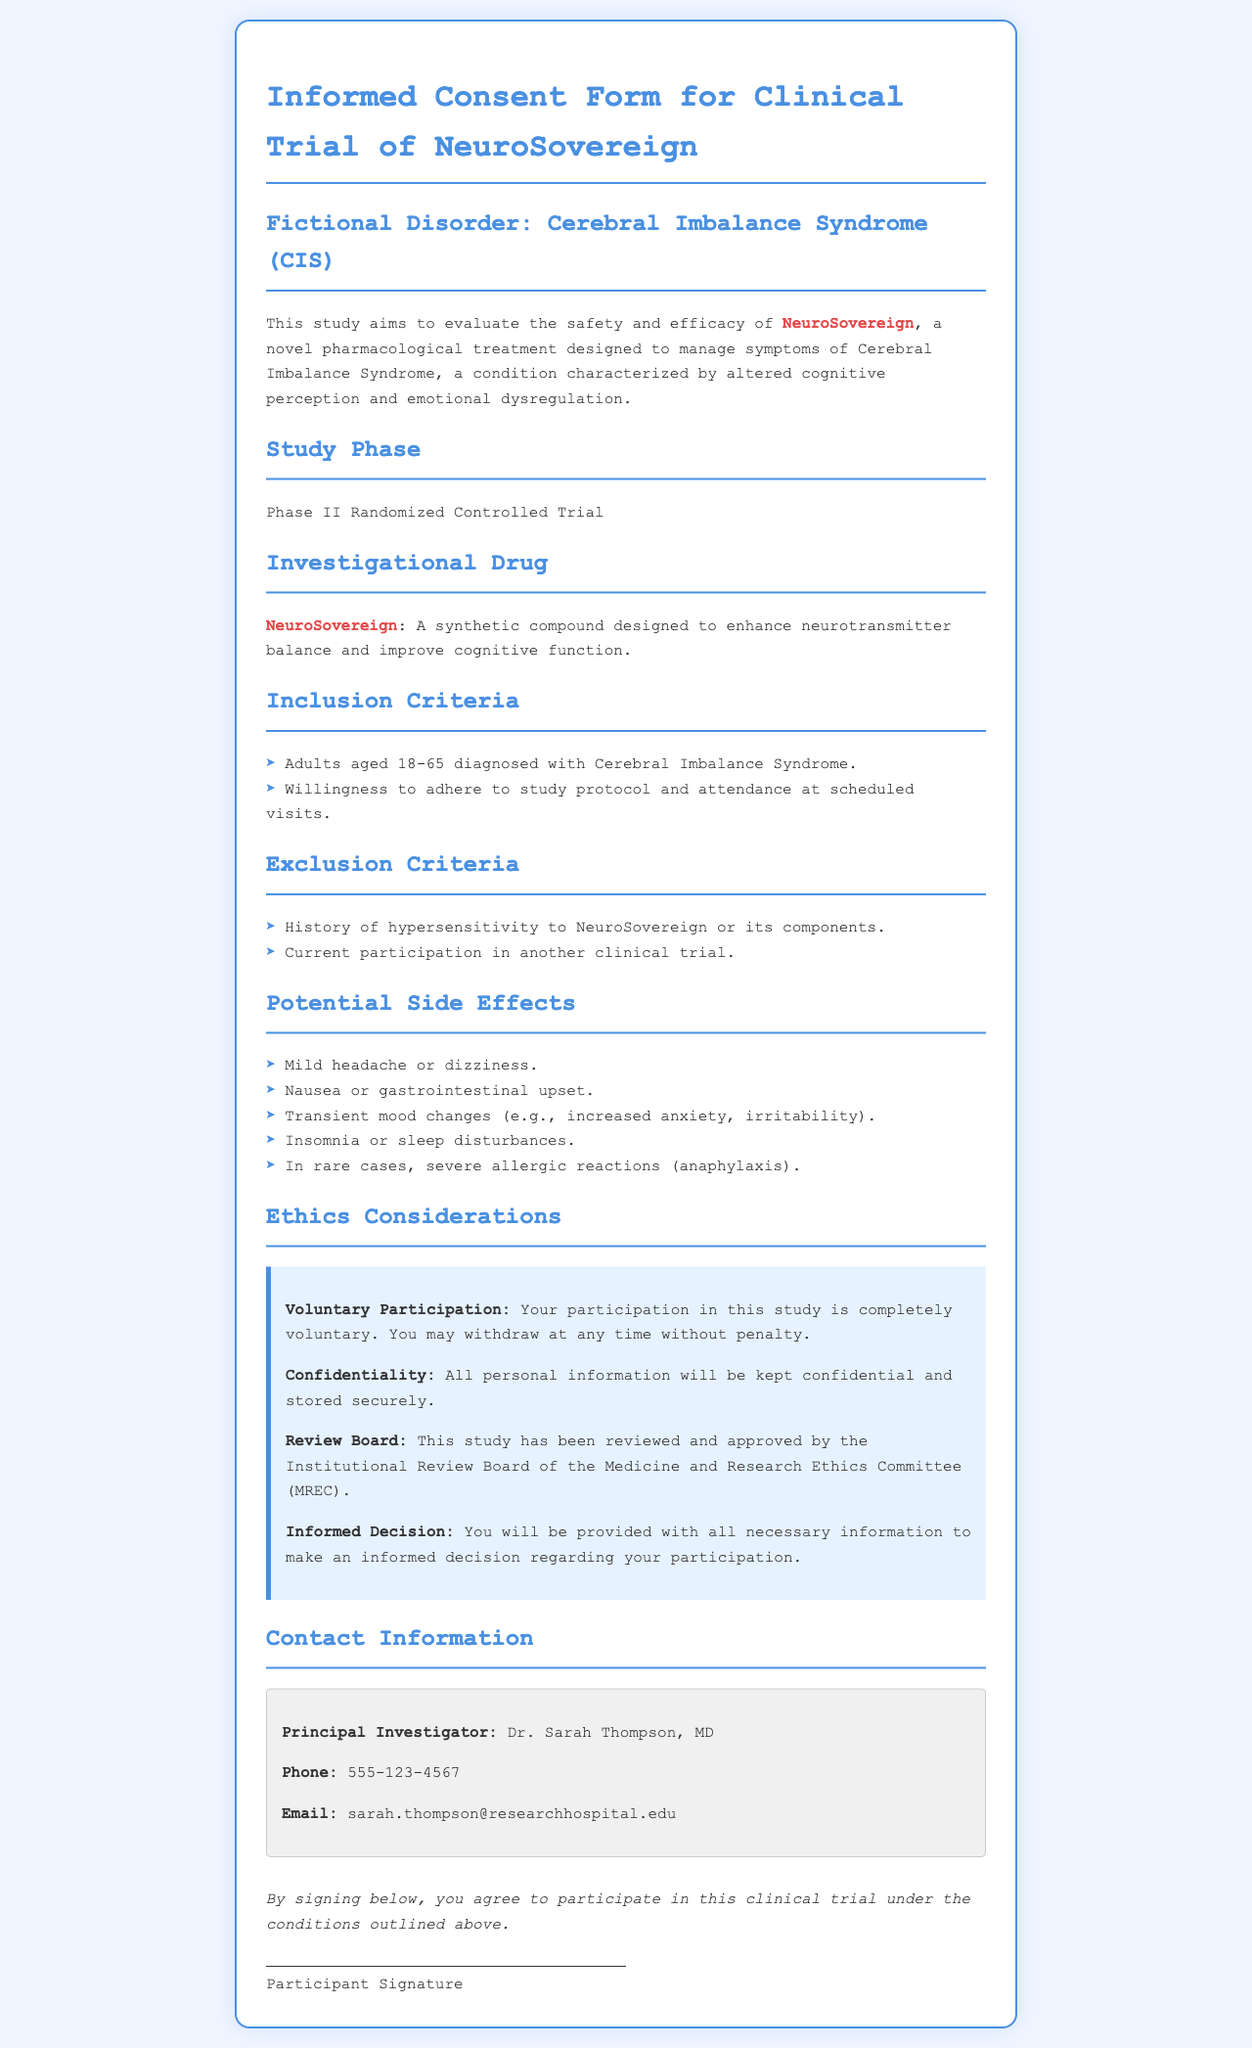What is the name of the investigational drug? The name of the investigational drug stated in the document is NeuroSovereign.
Answer: NeuroSovereign What is the age range for inclusion in the study? The document specifies that participants must be adults aged 18-65 to meet the inclusion criteria.
Answer: 18-65 What is one potential side effect listed? The document lists several potential side effects of the drug, including mild headache or dizziness as one of them.
Answer: Mild headache or dizziness Who is the principal investigator? The document mentions Dr. Sarah Thompson, MD, as the principal investigator leading the clinical trial.
Answer: Dr. Sarah Thompson, MD What does the ethics consideration state about participation? The ethics consideration states that participation is completely voluntary, allowing individuals to withdraw at any time without penalty.
Answer: Voluntary What is the purpose of the NeuroSovereign clinical trial? The study aims to evaluate the safety and efficacy of NeuroSovereign for managing symptoms of Cerebral Imbalance Syndrome.
Answer: Safety and efficacy How many exclusion criteria are listed in the document? There are two exclusion criteria mentioned in the document regarding participation in the clinical trial.
Answer: 2 What should participants sign to agree to the trial? Participants are required to sign the signature line at the bottom of the document to indicate their agreement to participate.
Answer: Signature line 